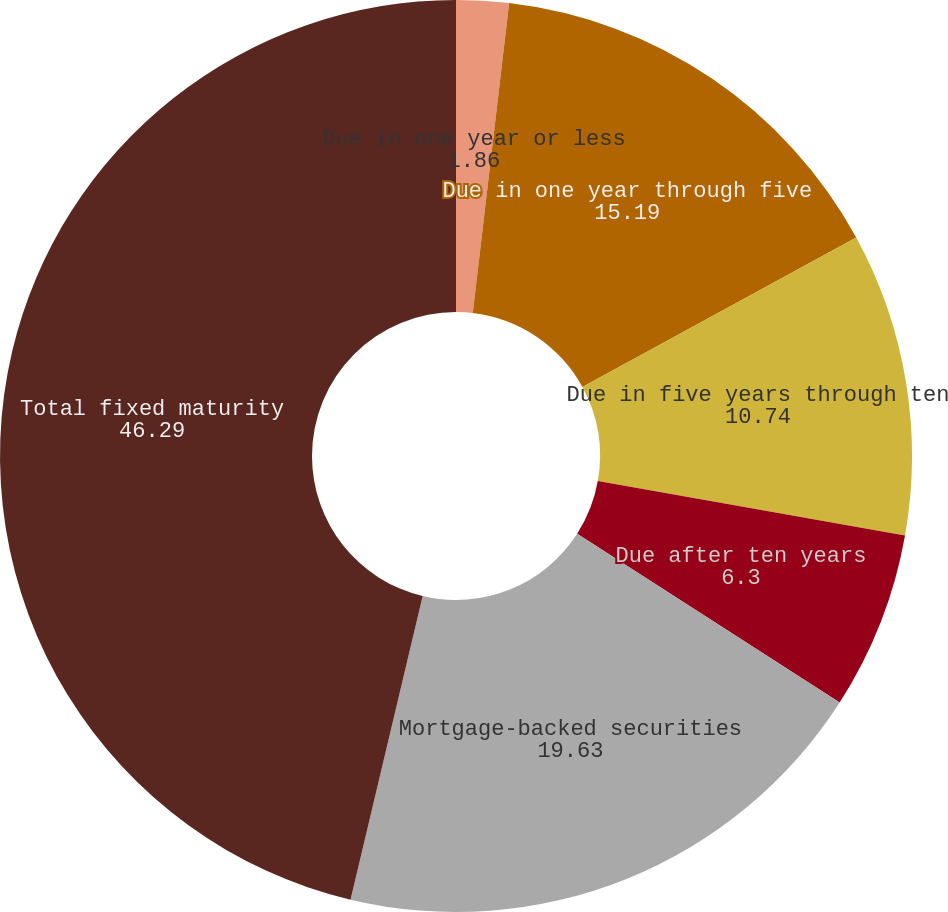<chart> <loc_0><loc_0><loc_500><loc_500><pie_chart><fcel>Due in one year or less<fcel>Due in one year through five<fcel>Due in five years through ten<fcel>Due after ten years<fcel>Mortgage-backed securities<fcel>Total fixed maturity<nl><fcel>1.86%<fcel>15.19%<fcel>10.74%<fcel>6.3%<fcel>19.63%<fcel>46.29%<nl></chart> 